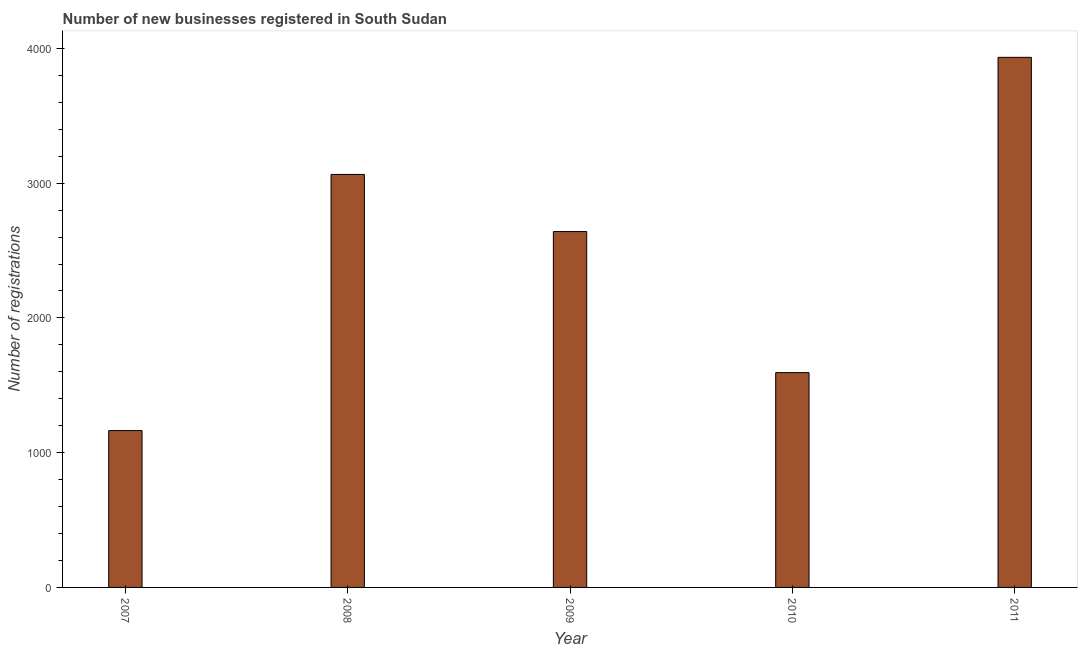Does the graph contain grids?
Offer a terse response. No. What is the title of the graph?
Ensure brevity in your answer.  Number of new businesses registered in South Sudan. What is the label or title of the X-axis?
Provide a succinct answer. Year. What is the label or title of the Y-axis?
Offer a very short reply. Number of registrations. What is the number of new business registrations in 2009?
Offer a terse response. 2641. Across all years, what is the maximum number of new business registrations?
Your answer should be compact. 3934. Across all years, what is the minimum number of new business registrations?
Your answer should be compact. 1164. In which year was the number of new business registrations minimum?
Offer a terse response. 2007. What is the sum of the number of new business registrations?
Provide a succinct answer. 1.24e+04. What is the difference between the number of new business registrations in 2009 and 2011?
Offer a very short reply. -1293. What is the average number of new business registrations per year?
Make the answer very short. 2479. What is the median number of new business registrations?
Provide a succinct answer. 2641. What is the ratio of the number of new business registrations in 2008 to that in 2010?
Make the answer very short. 1.92. Is the number of new business registrations in 2009 less than that in 2010?
Offer a very short reply. No. What is the difference between the highest and the second highest number of new business registrations?
Offer a terse response. 869. Is the sum of the number of new business registrations in 2010 and 2011 greater than the maximum number of new business registrations across all years?
Make the answer very short. Yes. What is the difference between the highest and the lowest number of new business registrations?
Give a very brief answer. 2770. In how many years, is the number of new business registrations greater than the average number of new business registrations taken over all years?
Your response must be concise. 3. How many bars are there?
Offer a very short reply. 5. What is the Number of registrations of 2007?
Provide a succinct answer. 1164. What is the Number of registrations of 2008?
Ensure brevity in your answer.  3065. What is the Number of registrations in 2009?
Give a very brief answer. 2641. What is the Number of registrations in 2010?
Provide a short and direct response. 1594. What is the Number of registrations of 2011?
Give a very brief answer. 3934. What is the difference between the Number of registrations in 2007 and 2008?
Provide a succinct answer. -1901. What is the difference between the Number of registrations in 2007 and 2009?
Keep it short and to the point. -1477. What is the difference between the Number of registrations in 2007 and 2010?
Provide a short and direct response. -430. What is the difference between the Number of registrations in 2007 and 2011?
Offer a terse response. -2770. What is the difference between the Number of registrations in 2008 and 2009?
Your answer should be compact. 424. What is the difference between the Number of registrations in 2008 and 2010?
Provide a succinct answer. 1471. What is the difference between the Number of registrations in 2008 and 2011?
Your answer should be very brief. -869. What is the difference between the Number of registrations in 2009 and 2010?
Ensure brevity in your answer.  1047. What is the difference between the Number of registrations in 2009 and 2011?
Your answer should be compact. -1293. What is the difference between the Number of registrations in 2010 and 2011?
Your answer should be compact. -2340. What is the ratio of the Number of registrations in 2007 to that in 2008?
Ensure brevity in your answer.  0.38. What is the ratio of the Number of registrations in 2007 to that in 2009?
Offer a terse response. 0.44. What is the ratio of the Number of registrations in 2007 to that in 2010?
Your answer should be very brief. 0.73. What is the ratio of the Number of registrations in 2007 to that in 2011?
Keep it short and to the point. 0.3. What is the ratio of the Number of registrations in 2008 to that in 2009?
Provide a short and direct response. 1.16. What is the ratio of the Number of registrations in 2008 to that in 2010?
Make the answer very short. 1.92. What is the ratio of the Number of registrations in 2008 to that in 2011?
Provide a succinct answer. 0.78. What is the ratio of the Number of registrations in 2009 to that in 2010?
Ensure brevity in your answer.  1.66. What is the ratio of the Number of registrations in 2009 to that in 2011?
Offer a very short reply. 0.67. What is the ratio of the Number of registrations in 2010 to that in 2011?
Your answer should be compact. 0.41. 